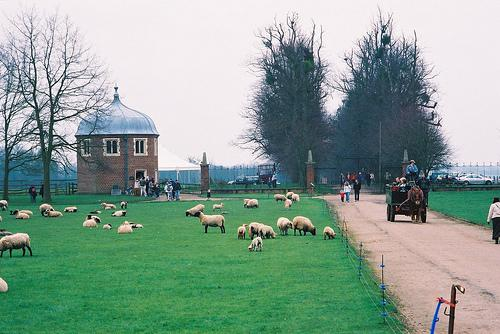Question: where are the sheep?
Choices:
A. In the shade.
B. In the fenced area.
C. By the river.
D. Grassy field.
Answer with the letter. Answer: D 